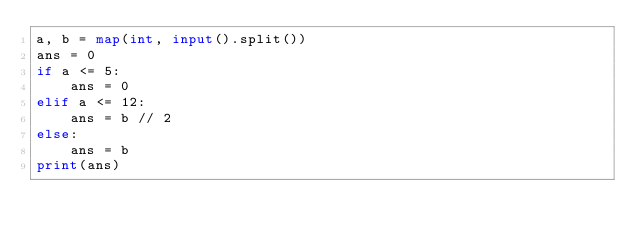Convert code to text. <code><loc_0><loc_0><loc_500><loc_500><_Python_>a, b = map(int, input().split())
ans = 0
if a <= 5:
    ans = 0
elif a <= 12:
    ans = b // 2
else:
    ans = b
print(ans)
</code> 